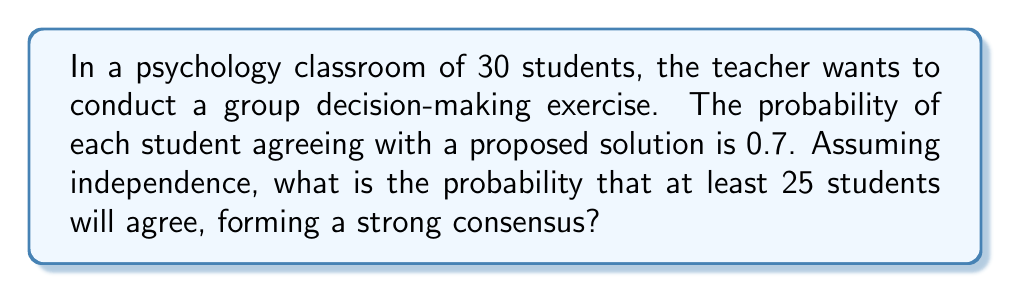Can you answer this question? To solve this problem, we need to use the binomial probability distribution. Let's break it down step-by-step:

1) We have a binomial situation because:
   - There are a fixed number of trials (n = 30 students)
   - Each trial has two possible outcomes (agree or disagree)
   - The probability of success (agreeing) is constant (p = 0.7)
   - The trials are independent

2) We want to find the probability of 25 or more students agreeing. This can be calculated as:

   P(X ≥ 25) = P(X = 25) + P(X = 26) + P(X = 27) + P(X = 28) + P(X = 29) + P(X = 30)

3) The binomial probability formula is:

   $$P(X = k) = \binom{n}{k} p^k (1-p)^{n-k}$$

   Where:
   n = total number of trials (30)
   k = number of successes
   p = probability of success on each trial (0.7)

4) Let's calculate each probability:

   $$P(X = 25) = \binom{30}{25} (0.7)^{25} (0.3)^5 = 0.1002$$
   $$P(X = 26) = \binom{30}{26} (0.7)^{26} (0.3)^4 = 0.1106$$
   $$P(X = 27) = \binom{30}{27} (0.7)^{27} (0.3)^3 = 0.0991$$
   $$P(X = 28) = \binom{30}{28} (0.7)^{28} (0.3)^2 = 0.0701$$
   $$P(X = 29) = \binom{30}{29} (0.7)^{29} (0.3)^1 = 0.0366$$
   $$P(X = 30) = \binom{30}{30} (0.7)^{30} (0.3)^0 = 0.0122$$

5) Sum these probabilities:

   P(X ≥ 25) = 0.1002 + 0.1106 + 0.0991 + 0.0701 + 0.0366 + 0.0122 = 0.4288

Therefore, the probability of at least 25 students agreeing (forming a strong consensus) is approximately 0.4288 or 42.88%.
Answer: 0.4288 or 42.88% 